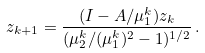Convert formula to latex. <formula><loc_0><loc_0><loc_500><loc_500>z _ { k + 1 } = \frac { ( I - A / \mu _ { 1 } ^ { k } ) z _ { k } } { ( \mu _ { 2 } ^ { k } / ( \mu _ { 1 } ^ { k } ) ^ { 2 } - 1 ) ^ { 1 / 2 } } \, .</formula> 